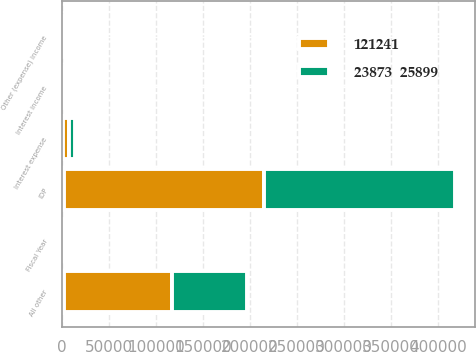<chart> <loc_0><loc_0><loc_500><loc_500><stacked_bar_chart><ecel><fcel>Fiscal Year<fcel>IDP<fcel>All other<fcel>Interest expense<fcel>Interest income<fcel>Other (expense) income<nl><fcel>nan<fcel>2015<fcel>2014.5<fcel>2014.5<fcel>1421<fcel>450<fcel>254<nl><fcel>121241<fcel>2014<fcel>212897<fcel>114836<fcel>5983<fcel>179<fcel>2336<nl><fcel>23873  25899<fcel>2013<fcel>202722<fcel>79435<fcel>6532<fcel>249<fcel>1180<nl></chart> 